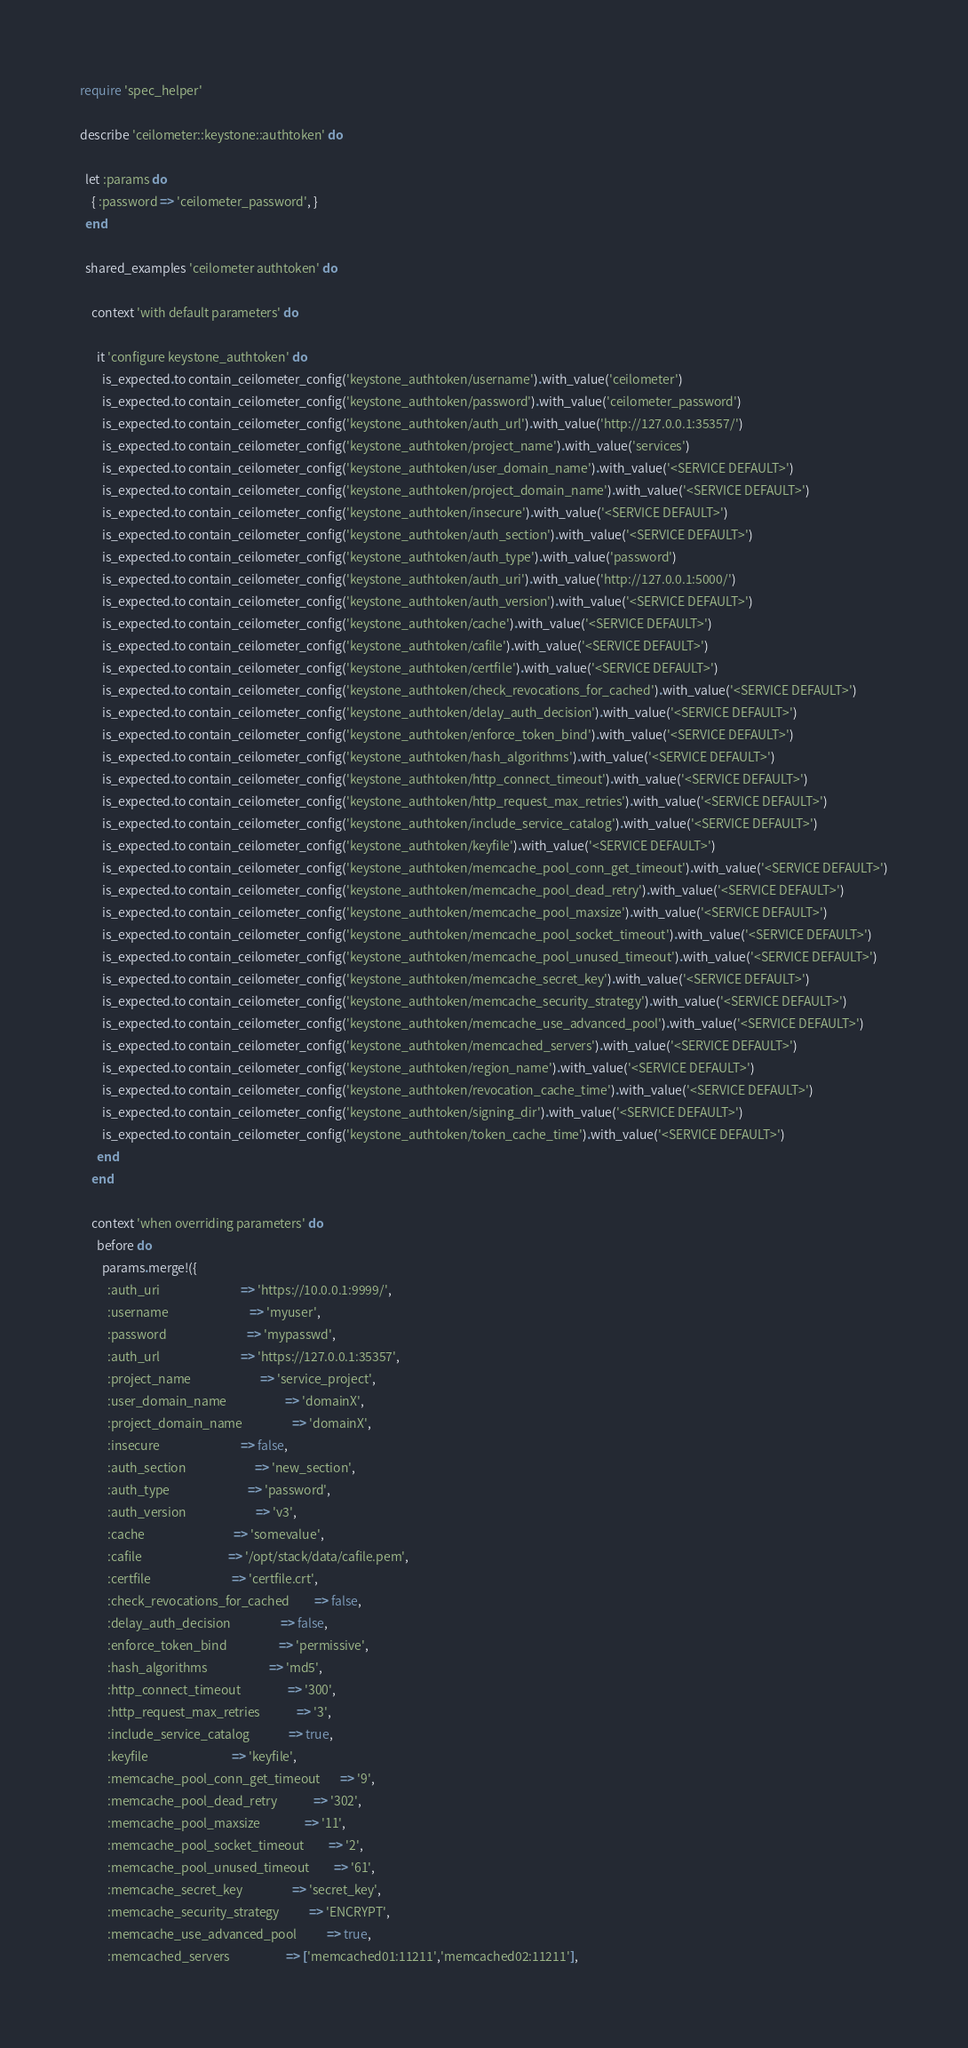Convert code to text. <code><loc_0><loc_0><loc_500><loc_500><_Ruby_>require 'spec_helper'

describe 'ceilometer::keystone::authtoken' do

  let :params do
    { :password => 'ceilometer_password', }
  end

  shared_examples 'ceilometer authtoken' do

    context 'with default parameters' do

      it 'configure keystone_authtoken' do
        is_expected.to contain_ceilometer_config('keystone_authtoken/username').with_value('ceilometer')
        is_expected.to contain_ceilometer_config('keystone_authtoken/password').with_value('ceilometer_password')
        is_expected.to contain_ceilometer_config('keystone_authtoken/auth_url').with_value('http://127.0.0.1:35357/')
        is_expected.to contain_ceilometer_config('keystone_authtoken/project_name').with_value('services')
        is_expected.to contain_ceilometer_config('keystone_authtoken/user_domain_name').with_value('<SERVICE DEFAULT>')
        is_expected.to contain_ceilometer_config('keystone_authtoken/project_domain_name').with_value('<SERVICE DEFAULT>')
        is_expected.to contain_ceilometer_config('keystone_authtoken/insecure').with_value('<SERVICE DEFAULT>')
        is_expected.to contain_ceilometer_config('keystone_authtoken/auth_section').with_value('<SERVICE DEFAULT>')
        is_expected.to contain_ceilometer_config('keystone_authtoken/auth_type').with_value('password')
        is_expected.to contain_ceilometer_config('keystone_authtoken/auth_uri').with_value('http://127.0.0.1:5000/')
        is_expected.to contain_ceilometer_config('keystone_authtoken/auth_version').with_value('<SERVICE DEFAULT>')
        is_expected.to contain_ceilometer_config('keystone_authtoken/cache').with_value('<SERVICE DEFAULT>')
        is_expected.to contain_ceilometer_config('keystone_authtoken/cafile').with_value('<SERVICE DEFAULT>')
        is_expected.to contain_ceilometer_config('keystone_authtoken/certfile').with_value('<SERVICE DEFAULT>')
        is_expected.to contain_ceilometer_config('keystone_authtoken/check_revocations_for_cached').with_value('<SERVICE DEFAULT>')
        is_expected.to contain_ceilometer_config('keystone_authtoken/delay_auth_decision').with_value('<SERVICE DEFAULT>')
        is_expected.to contain_ceilometer_config('keystone_authtoken/enforce_token_bind').with_value('<SERVICE DEFAULT>')
        is_expected.to contain_ceilometer_config('keystone_authtoken/hash_algorithms').with_value('<SERVICE DEFAULT>')
        is_expected.to contain_ceilometer_config('keystone_authtoken/http_connect_timeout').with_value('<SERVICE DEFAULT>')
        is_expected.to contain_ceilometer_config('keystone_authtoken/http_request_max_retries').with_value('<SERVICE DEFAULT>')
        is_expected.to contain_ceilometer_config('keystone_authtoken/include_service_catalog').with_value('<SERVICE DEFAULT>')
        is_expected.to contain_ceilometer_config('keystone_authtoken/keyfile').with_value('<SERVICE DEFAULT>')
        is_expected.to contain_ceilometer_config('keystone_authtoken/memcache_pool_conn_get_timeout').with_value('<SERVICE DEFAULT>')
        is_expected.to contain_ceilometer_config('keystone_authtoken/memcache_pool_dead_retry').with_value('<SERVICE DEFAULT>')
        is_expected.to contain_ceilometer_config('keystone_authtoken/memcache_pool_maxsize').with_value('<SERVICE DEFAULT>')
        is_expected.to contain_ceilometer_config('keystone_authtoken/memcache_pool_socket_timeout').with_value('<SERVICE DEFAULT>')
        is_expected.to contain_ceilometer_config('keystone_authtoken/memcache_pool_unused_timeout').with_value('<SERVICE DEFAULT>')
        is_expected.to contain_ceilometer_config('keystone_authtoken/memcache_secret_key').with_value('<SERVICE DEFAULT>')
        is_expected.to contain_ceilometer_config('keystone_authtoken/memcache_security_strategy').with_value('<SERVICE DEFAULT>')
        is_expected.to contain_ceilometer_config('keystone_authtoken/memcache_use_advanced_pool').with_value('<SERVICE DEFAULT>')
        is_expected.to contain_ceilometer_config('keystone_authtoken/memcached_servers').with_value('<SERVICE DEFAULT>')
        is_expected.to contain_ceilometer_config('keystone_authtoken/region_name').with_value('<SERVICE DEFAULT>')
        is_expected.to contain_ceilometer_config('keystone_authtoken/revocation_cache_time').with_value('<SERVICE DEFAULT>')
        is_expected.to contain_ceilometer_config('keystone_authtoken/signing_dir').with_value('<SERVICE DEFAULT>')
        is_expected.to contain_ceilometer_config('keystone_authtoken/token_cache_time').with_value('<SERVICE DEFAULT>')
      end
    end

    context 'when overriding parameters' do
      before do
        params.merge!({
          :auth_uri                             => 'https://10.0.0.1:9999/',
          :username                             => 'myuser',
          :password                             => 'mypasswd',
          :auth_url                             => 'https://127.0.0.1:35357',
          :project_name                         => 'service_project',
          :user_domain_name                     => 'domainX',
          :project_domain_name                  => 'domainX',
          :insecure                             => false,
          :auth_section                         => 'new_section',
          :auth_type                            => 'password',
          :auth_version                         => 'v3',
          :cache                                => 'somevalue',
          :cafile                               => '/opt/stack/data/cafile.pem',
          :certfile                             => 'certfile.crt',
          :check_revocations_for_cached         => false,
          :delay_auth_decision                  => false,
          :enforce_token_bind                   => 'permissive',
          :hash_algorithms                      => 'md5',
          :http_connect_timeout                 => '300',
          :http_request_max_retries             => '3',
          :include_service_catalog              => true,
          :keyfile                              => 'keyfile',
          :memcache_pool_conn_get_timeout       => '9',
          :memcache_pool_dead_retry             => '302',
          :memcache_pool_maxsize                => '11',
          :memcache_pool_socket_timeout         => '2',
          :memcache_pool_unused_timeout         => '61',
          :memcache_secret_key                  => 'secret_key',
          :memcache_security_strategy           => 'ENCRYPT',
          :memcache_use_advanced_pool           => true,
          :memcached_servers                    => ['memcached01:11211','memcached02:11211'],</code> 